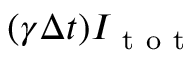Convert formula to latex. <formula><loc_0><loc_0><loc_500><loc_500>( \gamma \Delta t ) I _ { t o t }</formula> 